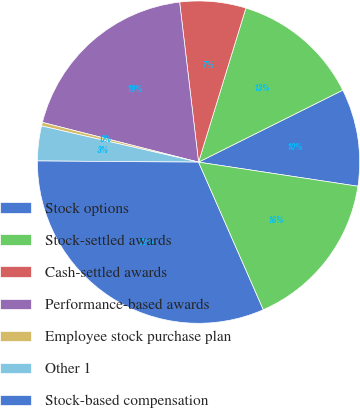Convert chart. <chart><loc_0><loc_0><loc_500><loc_500><pie_chart><fcel>Stock options<fcel>Stock-settled awards<fcel>Cash-settled awards<fcel>Performance-based awards<fcel>Employee stock purchase plan<fcel>Other 1<fcel>Stock-based compensation<fcel>Tax benefit<nl><fcel>9.76%<fcel>12.89%<fcel>6.62%<fcel>19.16%<fcel>0.36%<fcel>3.49%<fcel>31.7%<fcel>16.03%<nl></chart> 